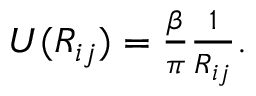<formula> <loc_0><loc_0><loc_500><loc_500>\begin{array} { r } { U ( R _ { i j } ) = \frac { \beta } { \pi } \frac { 1 } { R _ { i j } } . } \end{array}</formula> 